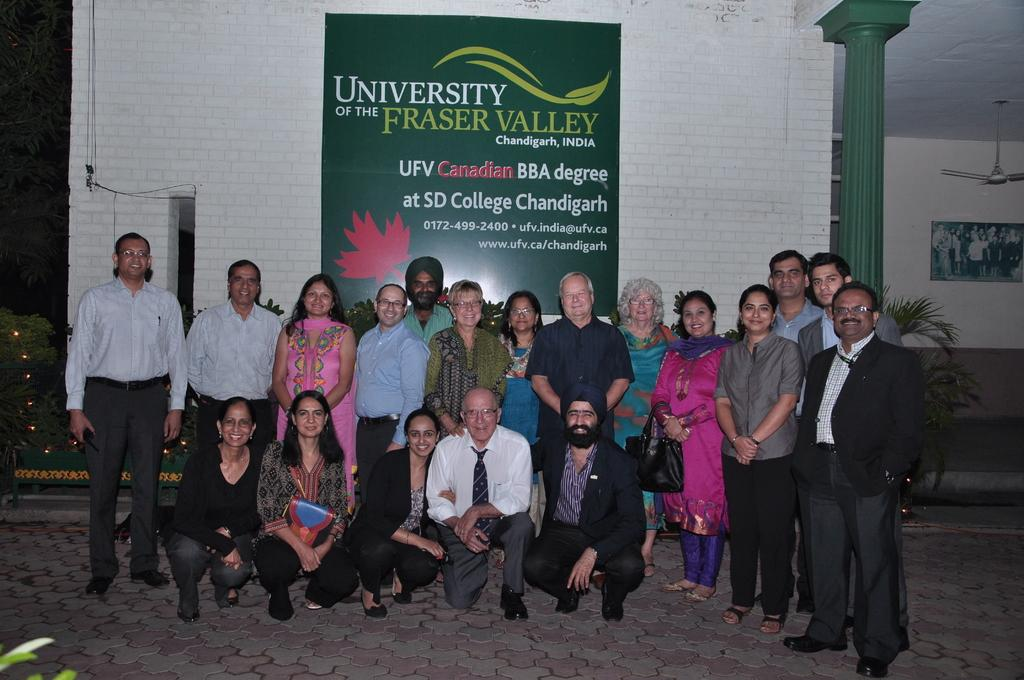How many people are in the image? There is a group of people in the image. What are the people wearing? The people are wearing different color dresses. What can be seen in the background of the image? There is a building, a green board, a pillar, a fan, and a frame attached to the wall in the background of the image. What type of berry is growing on the tree in the image? There is no tree or berry present in the image. What kind of apparatus is being used by the people in the image? The image does not show any specific apparatus being used by the people; they are simply standing and wearing different color dresses. 